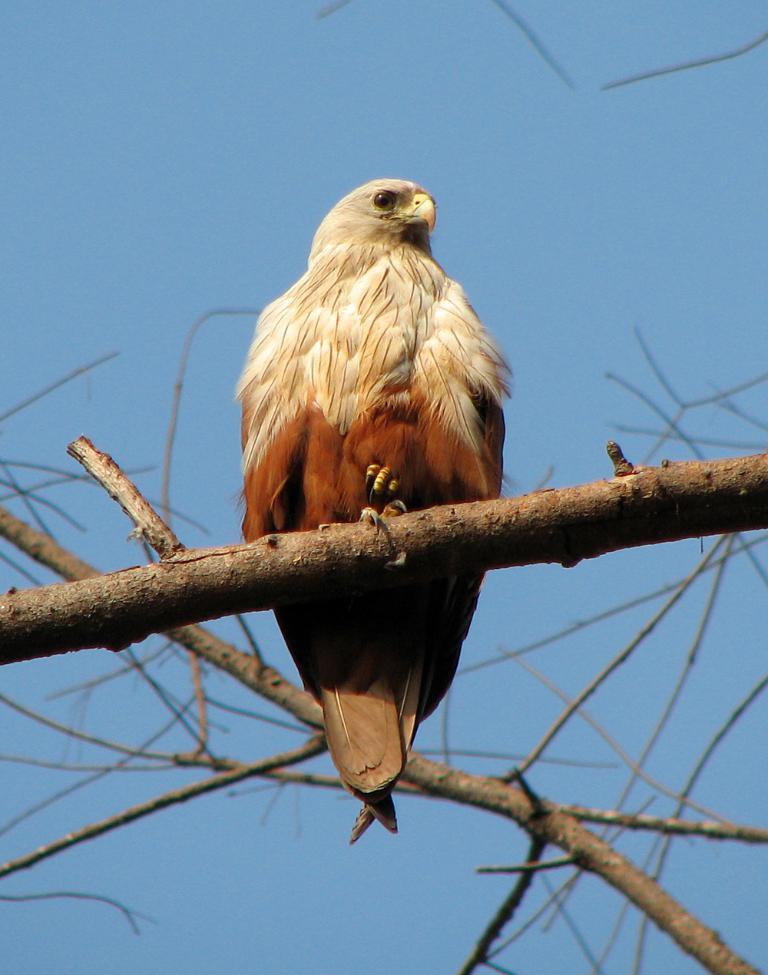Describe this image in one or two sentences. In this image we can see a eagle standing on the branch of a tree. In the background we can see the sky. 